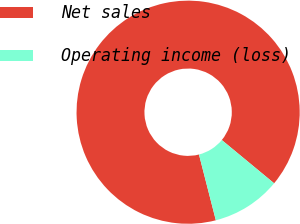<chart> <loc_0><loc_0><loc_500><loc_500><pie_chart><fcel>Net sales<fcel>Operating income (loss)<nl><fcel>89.99%<fcel>10.01%<nl></chart> 